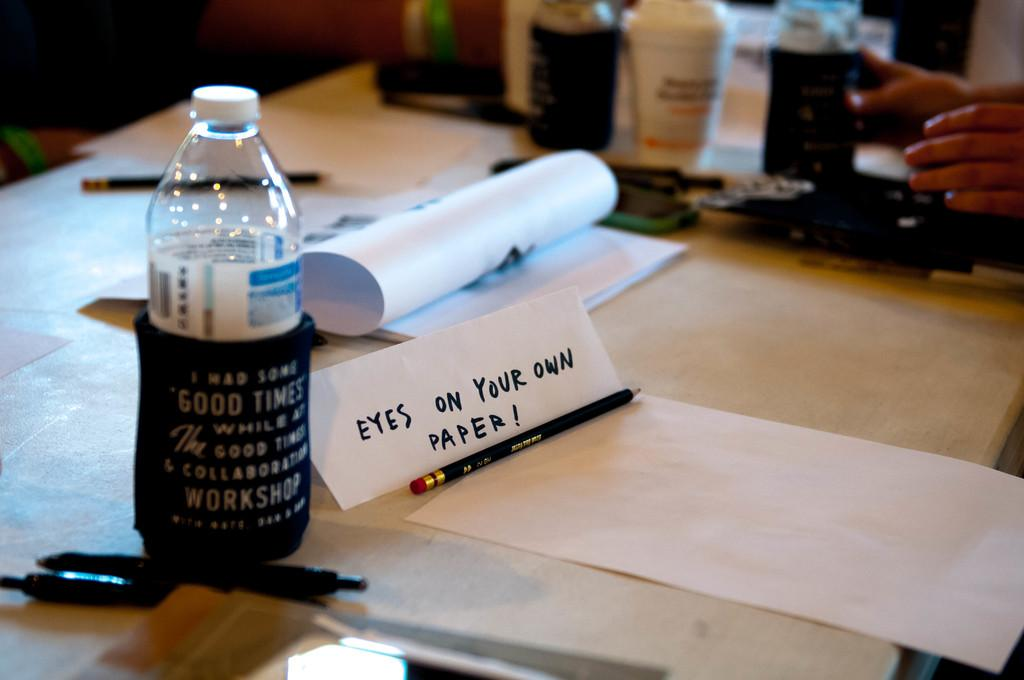<image>
Provide a brief description of the given image. A paper with the words eyes on your own paper with a pencil in front of it. 